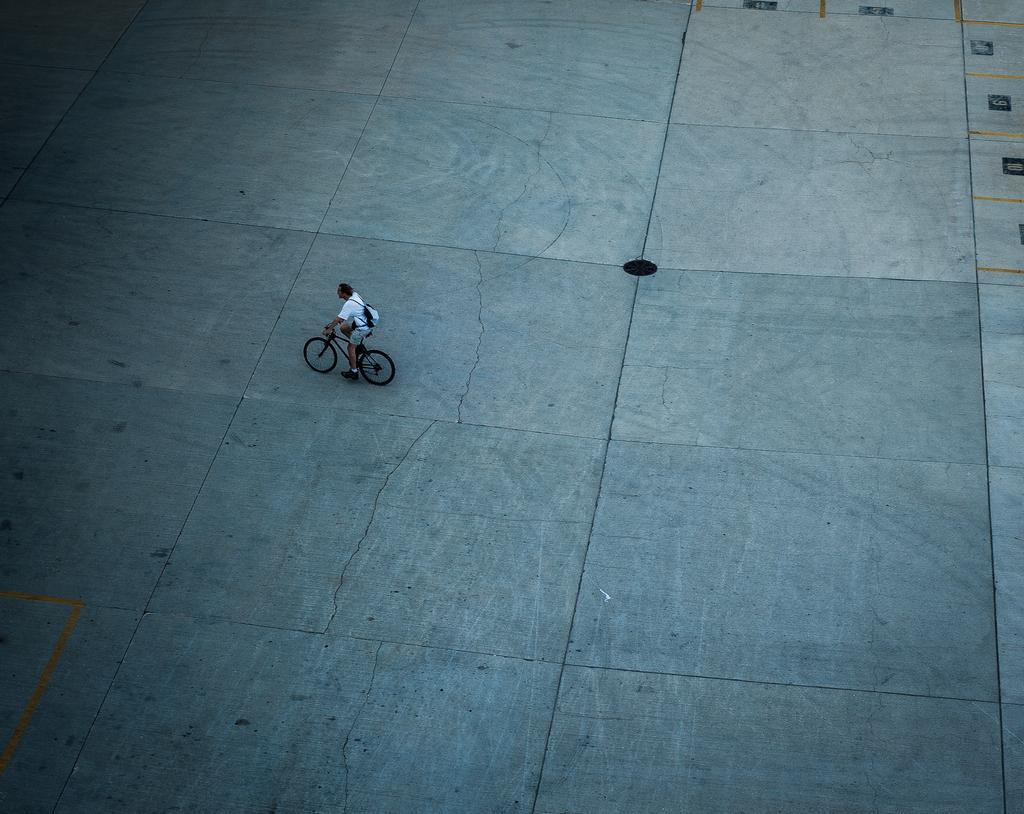Could you give a brief overview of what you see in this image? This image is taken outdoors. At the bottom of the image there is a floor. In the middle of the image a man is riding on the bicycle. 